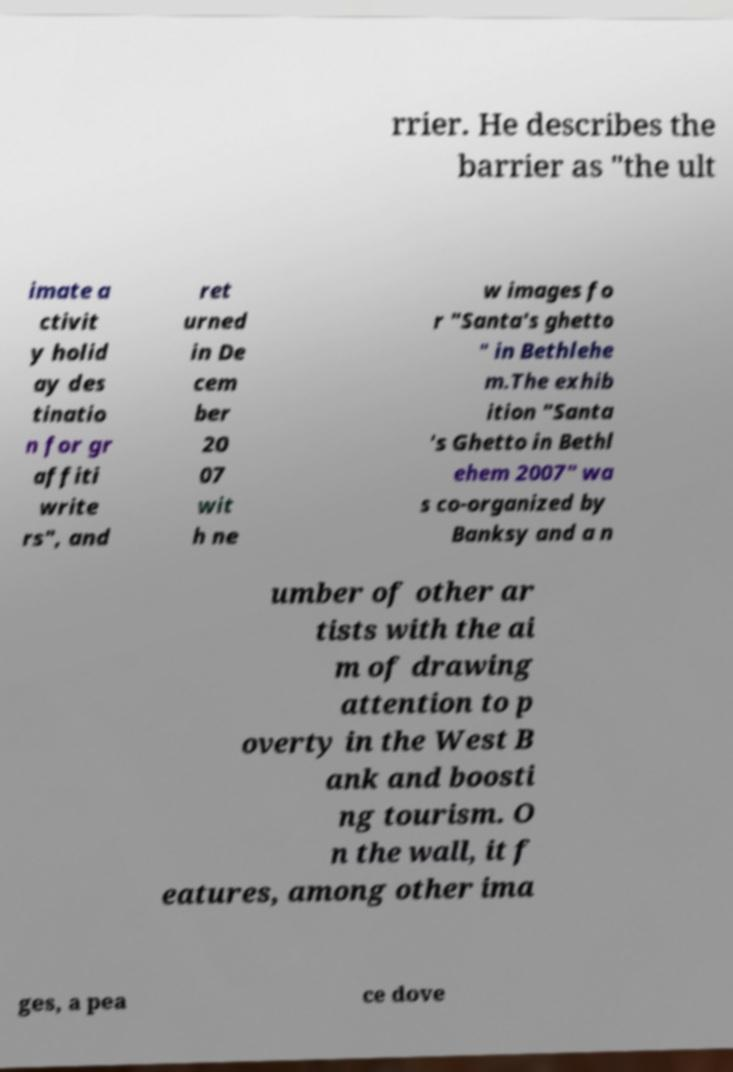Could you extract and type out the text from this image? rrier. He describes the barrier as "the ult imate a ctivit y holid ay des tinatio n for gr affiti write rs", and ret urned in De cem ber 20 07 wit h ne w images fo r "Santa's ghetto " in Bethlehe m.The exhib ition "Santa 's Ghetto in Bethl ehem 2007" wa s co-organized by Banksy and a n umber of other ar tists with the ai m of drawing attention to p overty in the West B ank and boosti ng tourism. O n the wall, it f eatures, among other ima ges, a pea ce dove 